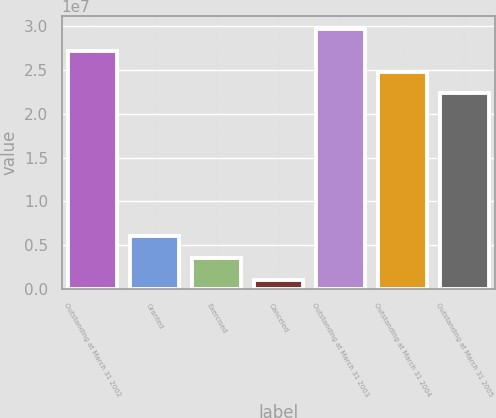<chart> <loc_0><loc_0><loc_500><loc_500><bar_chart><fcel>Outstanding at March 31 2002<fcel>Granted<fcel>Exercised<fcel>Canceled<fcel>Outstanding at March 31 2003<fcel>Outstanding at March 31 2004<fcel>Outstanding at March 31 2005<nl><fcel>2.72189e+07<fcel>5.989e+06<fcel>3.5649e+06<fcel>993899<fcel>2.9643e+07<fcel>2.47948e+07<fcel>2.23707e+07<nl></chart> 